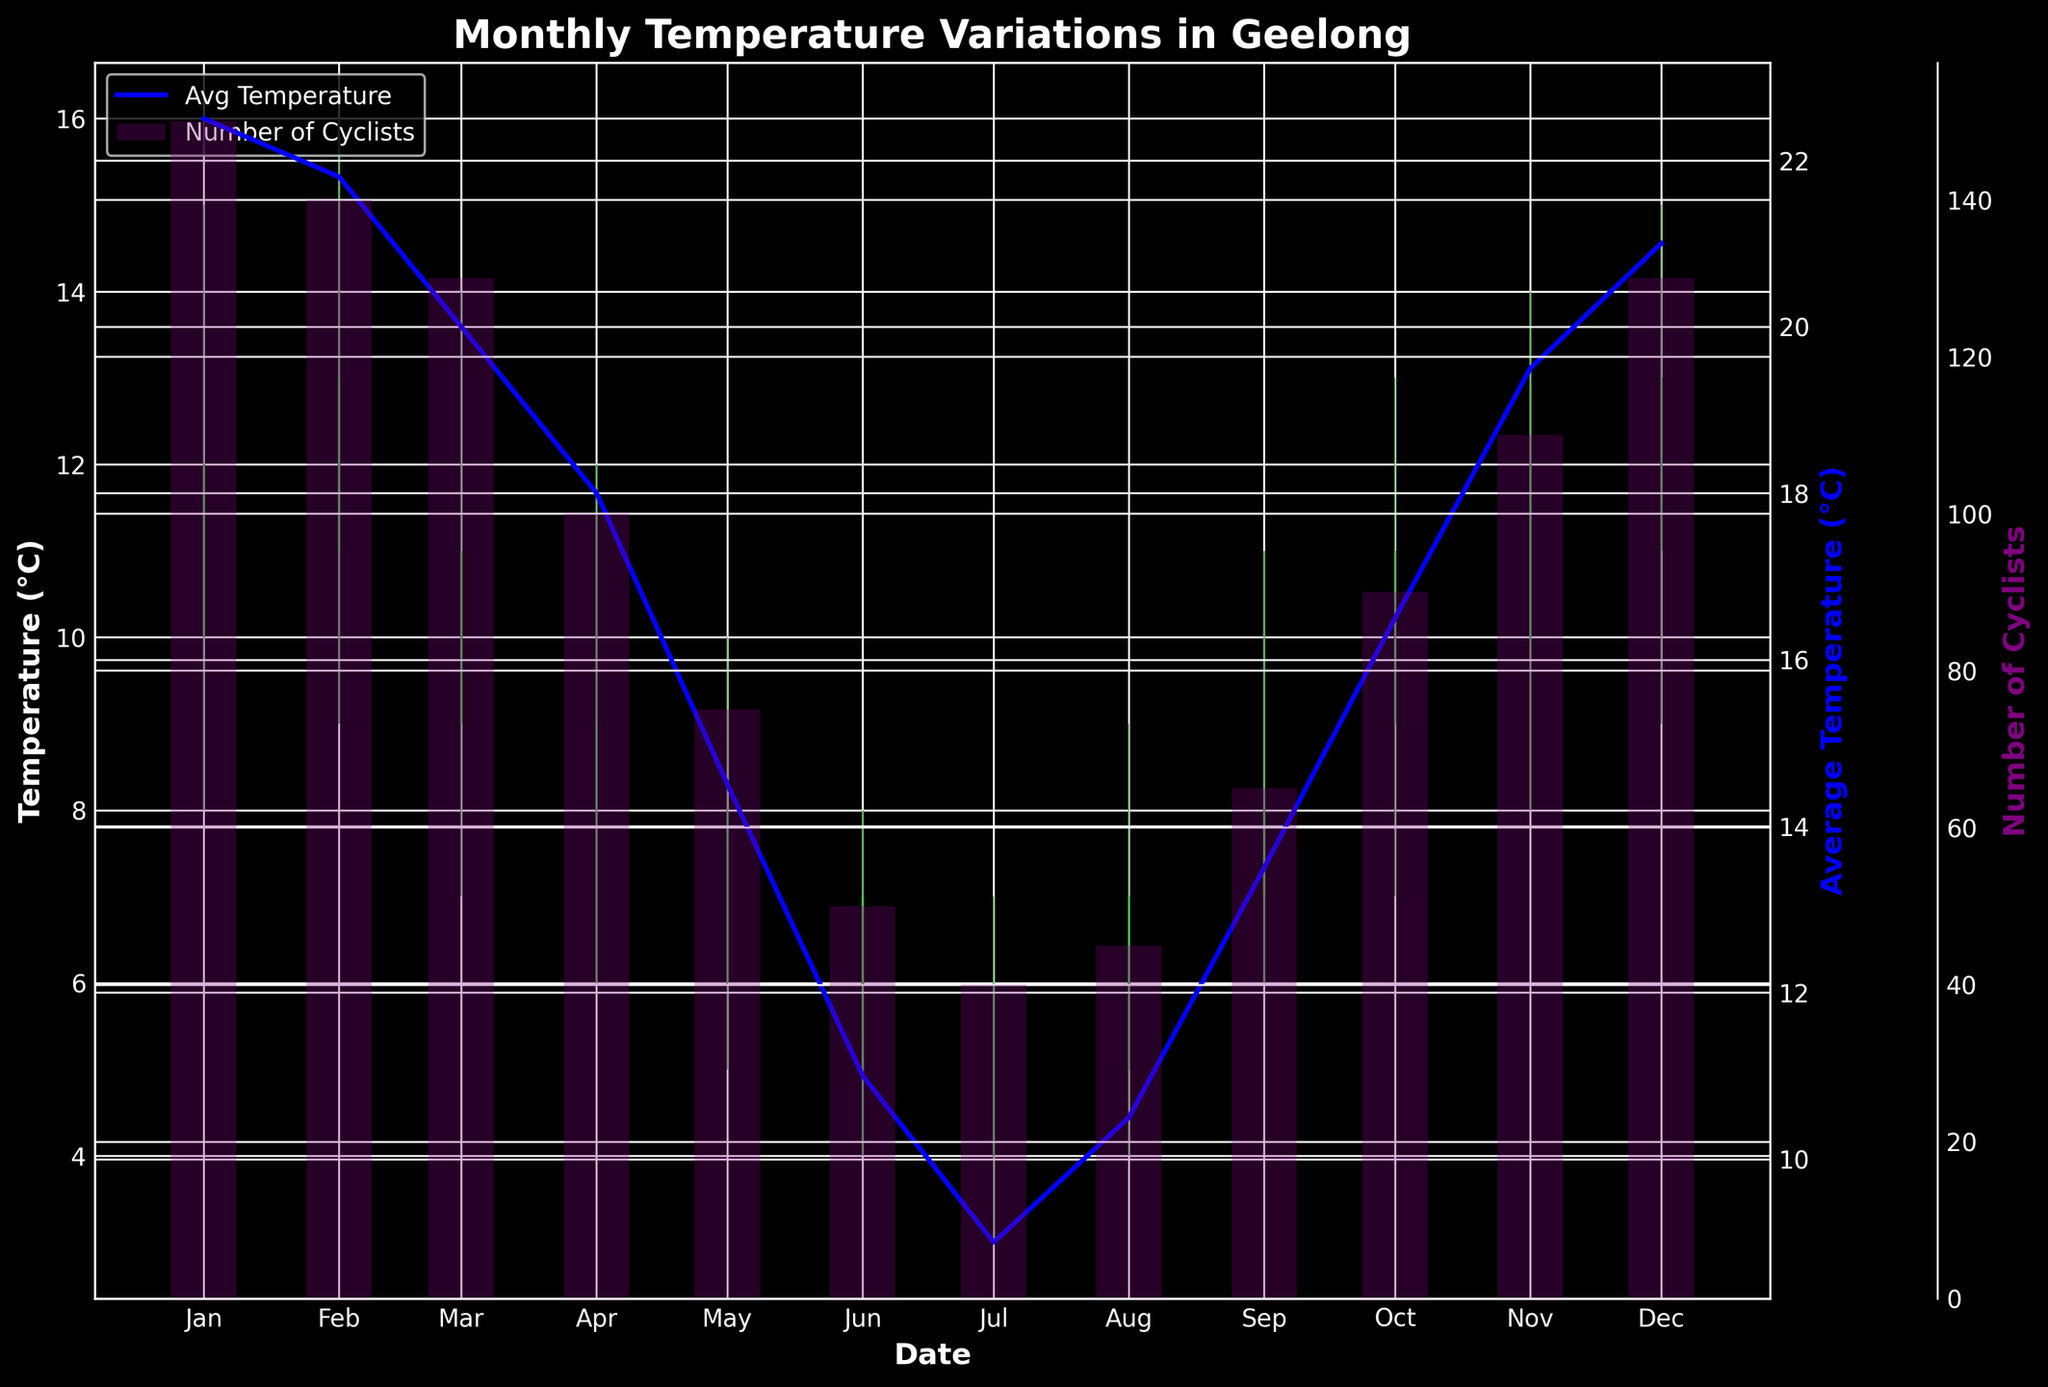What is the general trend of the average temperature throughout the year? By examining the blue line representing the average temperature across the months, it is clear that the average temperature is highest in January and decreases until July, before starting to increase again towards December.
Answer: Decreasing, then increasing How does the number of cyclists correlate with the average temperature? By comparing the blue line (average temperature) and purple bars (number of cyclists), we observe that higher temperatures generally correspond to a higher number of cyclists and lower temperatures correspond to fewer cyclists.
Answer: Positive correlation Which month experienced the highest maximum temperature and what was it? By looking for the highest point on the candlestick wicks, the highest maximum temperature is spotted in February, where the high is 16°C.
Answer: February, 16°C Which month had the lowest minimum temperature and what was it? By locating the lowest point on the candlestick wicks, the lowest minimum temperature occurred in July, where the low is 3°C.
Answer: July, 3°C In which month did the temperature remain the most stable (smallest difference between high and low)? Stability in temperature can be inferred by the shortest candlestick. May exhibits the smallest difference between high (10°C) and low (5°C), resulting in a difference of only 5°C.
Answer: May How many months had a higher closing temperature than an opening temperature? Green candlesticks indicate months where the closing temperature was higher than the opening temperature. There are four green candlesticks.
Answer: 4 months What is the relationship between the average temperature and the number of cyclists in June? June has an average temperature of 11.0°C and a corresponding number of cyclists of 50. This relationship continues the trend that lower temperatures yield fewer cyclists.
Answer: Lower temperature, fewer cyclists Which month saw the greatest increase in the number of cyclists compared to the previous month? Comparing the bar heights of the purple bars from one month to the next, September saw the largest increase in cyclists from 45 in August to 65 in September, a difference of 20 cyclists.
Answer: September Which month had the greatest difference between its high and low temperature? The length of the candlestick wicks shows this difference; March's high is 14°C and its low is 7°C, resulting in a 7°C difference.
Answer: March, 7°C In what month did the number of cyclists first drop below 100? The earliest purple bar that drops below the 100 mark represents this, which occurs in April, where the number of cyclists is 100.
Answer: April 